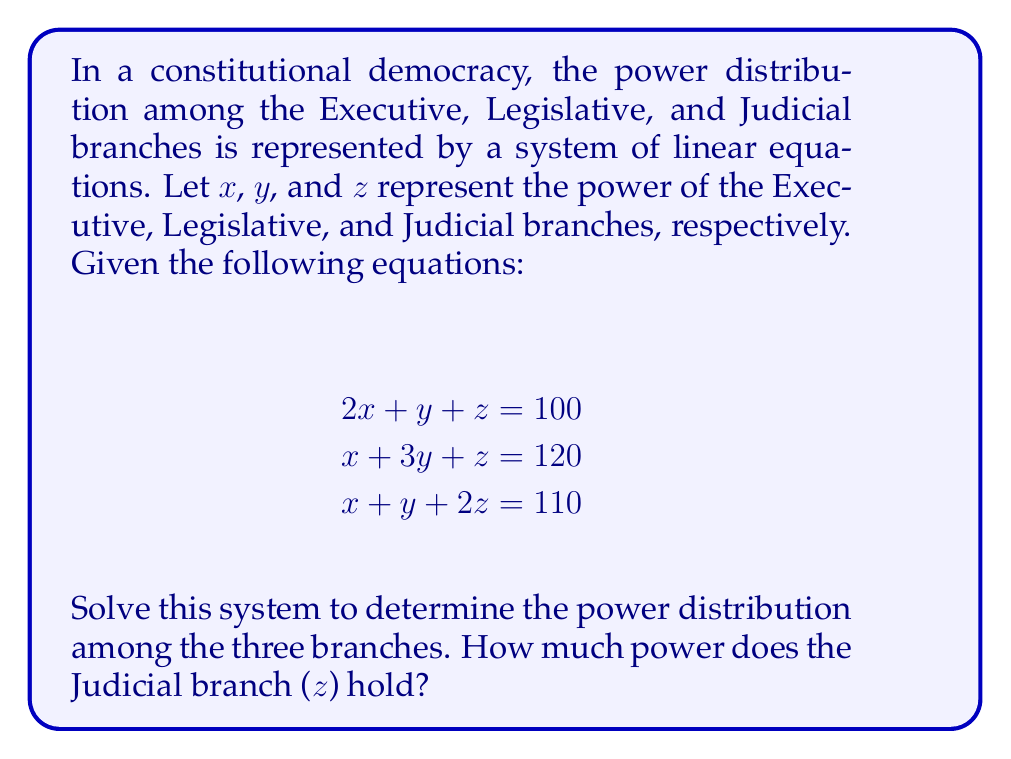Help me with this question. To solve this system of linear equations, we'll use the elimination method:

1) First, eliminate $x$ by subtracting equation (1) from equation (2):
   $$(x + 3y + z = 120) - (2x + y + z = 100)$$
   $$-x + 2y = 20 \quad \text{(4)}$$

2) Now, eliminate $x$ by subtracting equation (1) from equation (3):
   $$(x + y + 2z = 110) - (2x + y + z = 100)$$
   $$-x + z = 10 \quad \text{(5)}$$

3) From equation (5), we can express $x$ in terms of $z$:
   $$x = z - 10 \quad \text{(6)}$$

4) Substitute this into equation (4):
   $$-(z - 10) + 2y = 20$$
   $$-z + 10 + 2y = 20$$
   $$2y = z + 10 \quad \text{(7)}$$

5) Now substitute (6) and (7) into equation (1):
   $$2(z - 10) + (\frac{z + 10}{2}) + z = 100$$
   $$2z - 20 + \frac{z + 10}{2} + z = 100$$
   $$4z - 40 + z + 10 + 2z = 200$$
   $$7z - 30 = 200$$
   $$7z = 230$$
   $$z = \frac{230}{7} \approx 32.86$$

Therefore, the Judicial branch (z) holds approximately 32.86 units of power.
Answer: $z = \frac{230}{7} \approx 32.86$ 